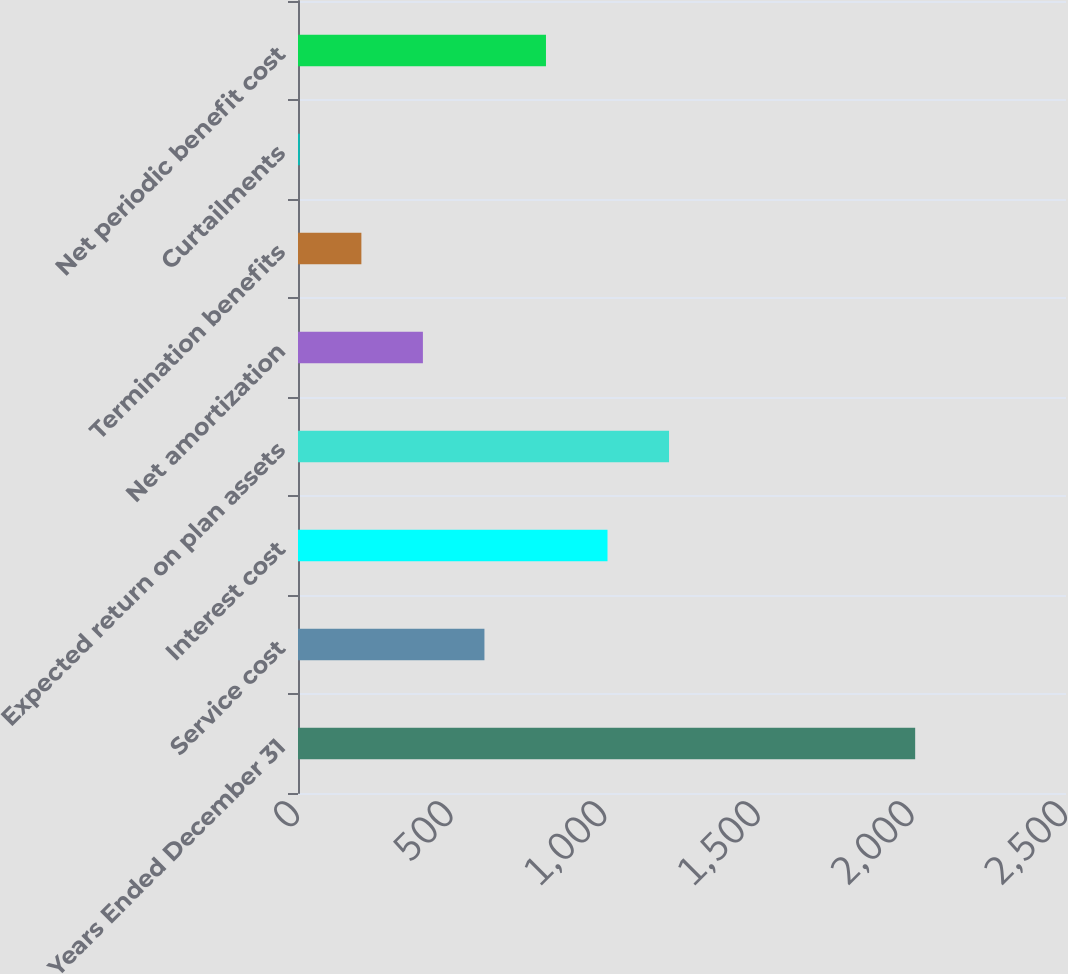Convert chart to OTSL. <chart><loc_0><loc_0><loc_500><loc_500><bar_chart><fcel>Years Ended December 31<fcel>Service cost<fcel>Interest cost<fcel>Expected return on plan assets<fcel>Net amortization<fcel>Termination benefits<fcel>Curtailments<fcel>Net periodic benefit cost<nl><fcel>2009<fcel>606.9<fcel>1007.5<fcel>1207.8<fcel>406.6<fcel>206.3<fcel>6<fcel>807.2<nl></chart> 